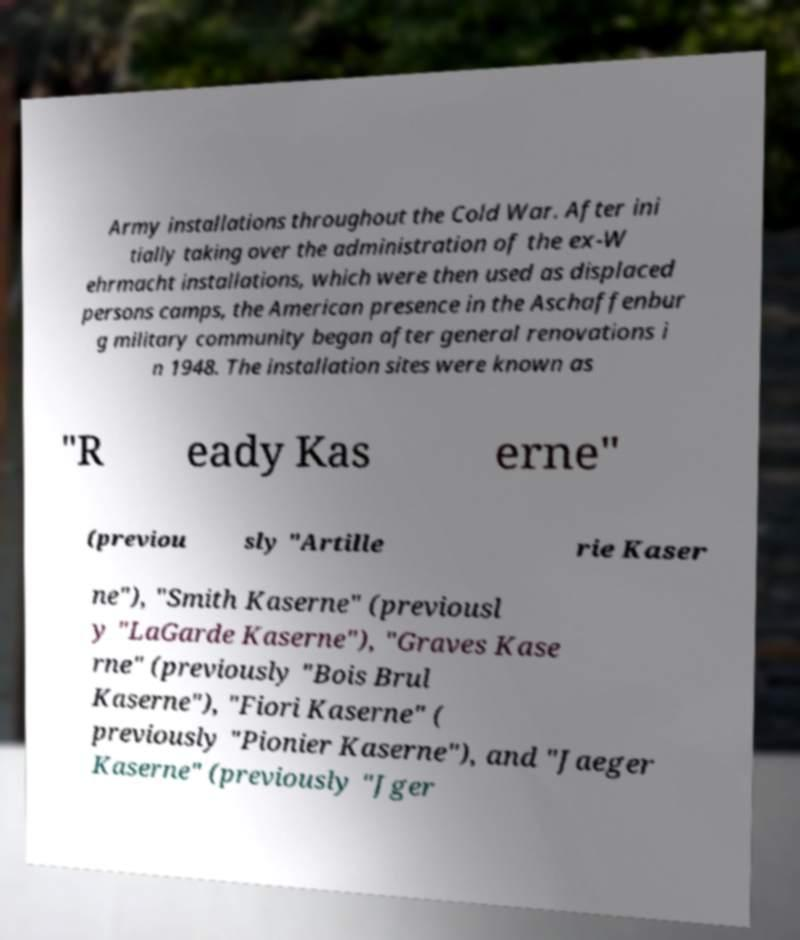For documentation purposes, I need the text within this image transcribed. Could you provide that? Army installations throughout the Cold War. After ini tially taking over the administration of the ex-W ehrmacht installations, which were then used as displaced persons camps, the American presence in the Aschaffenbur g military community began after general renovations i n 1948. The installation sites were known as "R eady Kas erne" (previou sly "Artille rie Kaser ne"), "Smith Kaserne" (previousl y "LaGarde Kaserne"), "Graves Kase rne" (previously "Bois Brul Kaserne"), "Fiori Kaserne" ( previously "Pionier Kaserne"), and "Jaeger Kaserne" (previously "Jger 